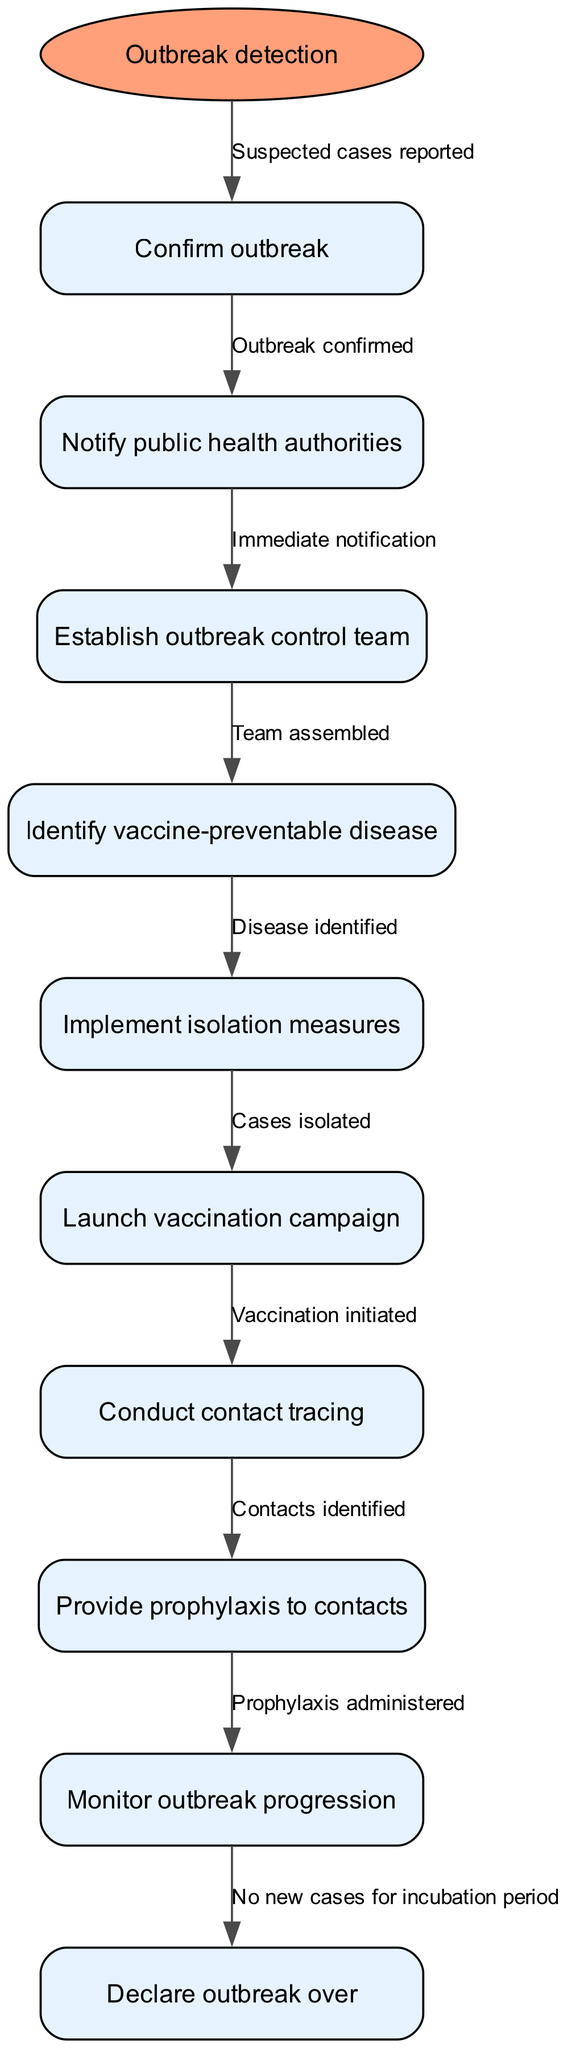what is the starting point of the clinical pathway? The starting point of the clinical pathway is labeled as "Outbreak detection." This indicates the initial stage before any actions are taken in response to the outbreak.
Answer: Outbreak detection how many nodes are there in the diagram? There are a total of 10 nodes in the diagram, including the starting point and the specific actions taken during the outbreak management process.
Answer: 10 what action follows the confirmation of an outbreak? Following the confirmation of an outbreak, the next action is to "Notify public health authorities." This is crucial for ensuring that appropriate measures can be taken by relevant health agencies.
Answer: Notify public health authorities which action is taken after isolating cases? After isolating cases, the next action is to "Launch vaccination campaign." This indicates the importance of vaccination in controlling the outbreak.
Answer: Launch vaccination campaign what is the final step in the clinical pathway? The final step in the clinical pathway is to "Declare outbreak over." This occurs once there are no new cases for the duration of the incubation period, indicating that the outbreak has been successfully managed.
Answer: Declare outbreak over which two actions are directly related to contact tracing? The two actions directly related to contact tracing are "Conduct contact tracing" and "Provide prophylaxis to contacts." These steps are essential for preventing further spread of the disease by identifying and supporting those who have been in contact with infectious individuals.
Answer: Conduct contact tracing, Provide prophylaxis to contacts what is required before the outbreak can be declared over? Before the outbreak can be declared over, it is required that "No new cases for incubation period" has been determined. This ensures that the outbreak is truly under control and not continuing silently.
Answer: No new cases for incubation period what is the relationship between establishing an outbreak control team and identifying the vaccine-preventable disease? The relationship is sequential; after "Establish outbreak control team," the next step is to "Identify vaccine-preventable disease." This indicates that the formation of a team is critical to facilitate the identification process and manage the response effectively.
Answer: Identify vaccine-preventable disease what must happen immediately after an outbreak is confirmed? Immediately after an outbreak is confirmed, it is necessary to "Notify public health authorities." This action is critical for initiating a coordinated response to control the outbreak effectively.
Answer: Notify public health authorities 